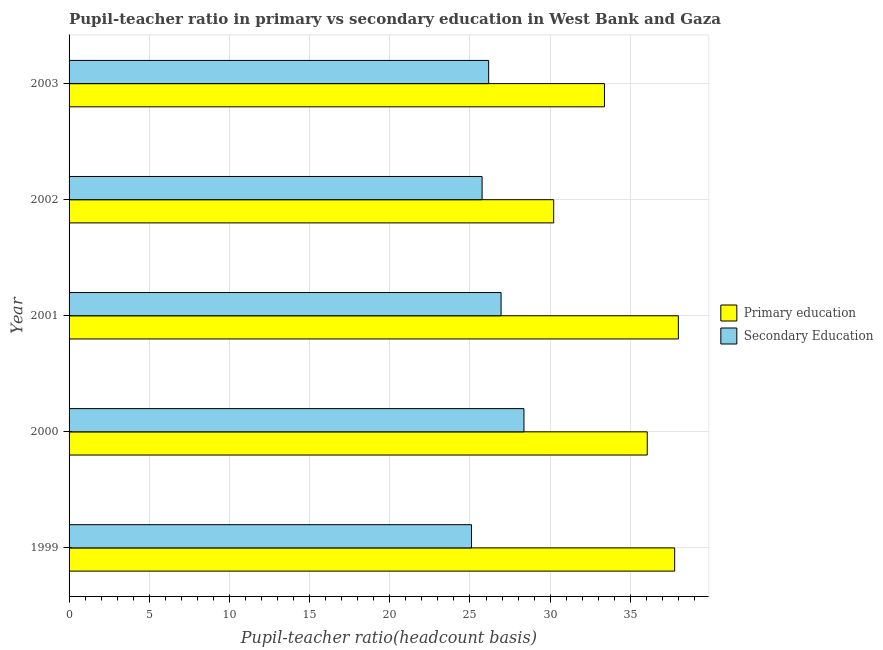How many different coloured bars are there?
Give a very brief answer. 2. How many groups of bars are there?
Your response must be concise. 5. Are the number of bars per tick equal to the number of legend labels?
Your response must be concise. Yes. How many bars are there on the 4th tick from the top?
Your response must be concise. 2. What is the pupil teacher ratio on secondary education in 2002?
Ensure brevity in your answer.  25.76. Across all years, what is the maximum pupil-teacher ratio in primary education?
Your answer should be compact. 37.99. Across all years, what is the minimum pupil teacher ratio on secondary education?
Make the answer very short. 25.1. In which year was the pupil-teacher ratio in primary education maximum?
Your response must be concise. 2001. What is the total pupil-teacher ratio in primary education in the graph?
Your answer should be very brief. 175.42. What is the difference between the pupil-teacher ratio in primary education in 1999 and that in 2002?
Provide a succinct answer. 7.55. What is the difference between the pupil-teacher ratio in primary education in 1999 and the pupil teacher ratio on secondary education in 2001?
Ensure brevity in your answer.  10.83. What is the average pupil-teacher ratio in primary education per year?
Offer a very short reply. 35.08. In the year 2001, what is the difference between the pupil teacher ratio on secondary education and pupil-teacher ratio in primary education?
Provide a short and direct response. -11.05. In how many years, is the pupil teacher ratio on secondary education greater than 22 ?
Your response must be concise. 5. What is the ratio of the pupil-teacher ratio in primary education in 1999 to that in 2000?
Keep it short and to the point. 1.05. What is the difference between the highest and the second highest pupil-teacher ratio in primary education?
Offer a very short reply. 0.23. What is the difference between the highest and the lowest pupil-teacher ratio in primary education?
Your answer should be compact. 7.77. Is the sum of the pupil-teacher ratio in primary education in 1999 and 2000 greater than the maximum pupil teacher ratio on secondary education across all years?
Your answer should be very brief. Yes. What does the 2nd bar from the top in 2001 represents?
Offer a very short reply. Primary education. What does the 1st bar from the bottom in 2003 represents?
Ensure brevity in your answer.  Primary education. How many bars are there?
Offer a very short reply. 10. Are the values on the major ticks of X-axis written in scientific E-notation?
Ensure brevity in your answer.  No. Does the graph contain grids?
Provide a short and direct response. Yes. How many legend labels are there?
Offer a terse response. 2. How are the legend labels stacked?
Your answer should be very brief. Vertical. What is the title of the graph?
Give a very brief answer. Pupil-teacher ratio in primary vs secondary education in West Bank and Gaza. What is the label or title of the X-axis?
Your answer should be compact. Pupil-teacher ratio(headcount basis). What is the label or title of the Y-axis?
Offer a terse response. Year. What is the Pupil-teacher ratio(headcount basis) in Primary education in 1999?
Offer a terse response. 37.76. What is the Pupil-teacher ratio(headcount basis) in Secondary Education in 1999?
Provide a succinct answer. 25.1. What is the Pupil-teacher ratio(headcount basis) in Primary education in 2000?
Give a very brief answer. 36.05. What is the Pupil-teacher ratio(headcount basis) of Secondary Education in 2000?
Offer a terse response. 28.37. What is the Pupil-teacher ratio(headcount basis) of Primary education in 2001?
Offer a terse response. 37.99. What is the Pupil-teacher ratio(headcount basis) in Secondary Education in 2001?
Your answer should be compact. 26.94. What is the Pupil-teacher ratio(headcount basis) of Primary education in 2002?
Offer a very short reply. 30.22. What is the Pupil-teacher ratio(headcount basis) in Secondary Education in 2002?
Your response must be concise. 25.76. What is the Pupil-teacher ratio(headcount basis) in Primary education in 2003?
Give a very brief answer. 33.39. What is the Pupil-teacher ratio(headcount basis) in Secondary Education in 2003?
Offer a terse response. 26.17. Across all years, what is the maximum Pupil-teacher ratio(headcount basis) in Primary education?
Offer a very short reply. 37.99. Across all years, what is the maximum Pupil-teacher ratio(headcount basis) of Secondary Education?
Offer a terse response. 28.37. Across all years, what is the minimum Pupil-teacher ratio(headcount basis) of Primary education?
Keep it short and to the point. 30.22. Across all years, what is the minimum Pupil-teacher ratio(headcount basis) of Secondary Education?
Provide a short and direct response. 25.1. What is the total Pupil-teacher ratio(headcount basis) in Primary education in the graph?
Make the answer very short. 175.42. What is the total Pupil-teacher ratio(headcount basis) of Secondary Education in the graph?
Offer a very short reply. 132.32. What is the difference between the Pupil-teacher ratio(headcount basis) in Primary education in 1999 and that in 2000?
Your answer should be very brief. 1.71. What is the difference between the Pupil-teacher ratio(headcount basis) in Secondary Education in 1999 and that in 2000?
Your answer should be very brief. -3.27. What is the difference between the Pupil-teacher ratio(headcount basis) of Primary education in 1999 and that in 2001?
Your response must be concise. -0.23. What is the difference between the Pupil-teacher ratio(headcount basis) in Secondary Education in 1999 and that in 2001?
Make the answer very short. -1.84. What is the difference between the Pupil-teacher ratio(headcount basis) in Primary education in 1999 and that in 2002?
Provide a short and direct response. 7.55. What is the difference between the Pupil-teacher ratio(headcount basis) of Secondary Education in 1999 and that in 2002?
Give a very brief answer. -0.66. What is the difference between the Pupil-teacher ratio(headcount basis) of Primary education in 1999 and that in 2003?
Make the answer very short. 4.38. What is the difference between the Pupil-teacher ratio(headcount basis) of Secondary Education in 1999 and that in 2003?
Offer a terse response. -1.07. What is the difference between the Pupil-teacher ratio(headcount basis) of Primary education in 2000 and that in 2001?
Your response must be concise. -1.94. What is the difference between the Pupil-teacher ratio(headcount basis) of Secondary Education in 2000 and that in 2001?
Provide a succinct answer. 1.43. What is the difference between the Pupil-teacher ratio(headcount basis) of Primary education in 2000 and that in 2002?
Your answer should be compact. 5.84. What is the difference between the Pupil-teacher ratio(headcount basis) of Secondary Education in 2000 and that in 2002?
Offer a terse response. 2.61. What is the difference between the Pupil-teacher ratio(headcount basis) in Primary education in 2000 and that in 2003?
Keep it short and to the point. 2.67. What is the difference between the Pupil-teacher ratio(headcount basis) in Secondary Education in 2000 and that in 2003?
Offer a very short reply. 2.2. What is the difference between the Pupil-teacher ratio(headcount basis) in Primary education in 2001 and that in 2002?
Make the answer very short. 7.78. What is the difference between the Pupil-teacher ratio(headcount basis) of Secondary Education in 2001 and that in 2002?
Offer a very short reply. 1.18. What is the difference between the Pupil-teacher ratio(headcount basis) in Primary education in 2001 and that in 2003?
Make the answer very short. 4.61. What is the difference between the Pupil-teacher ratio(headcount basis) in Secondary Education in 2001 and that in 2003?
Your answer should be very brief. 0.77. What is the difference between the Pupil-teacher ratio(headcount basis) in Primary education in 2002 and that in 2003?
Provide a short and direct response. -3.17. What is the difference between the Pupil-teacher ratio(headcount basis) of Secondary Education in 2002 and that in 2003?
Ensure brevity in your answer.  -0.41. What is the difference between the Pupil-teacher ratio(headcount basis) in Primary education in 1999 and the Pupil-teacher ratio(headcount basis) in Secondary Education in 2000?
Make the answer very short. 9.4. What is the difference between the Pupil-teacher ratio(headcount basis) of Primary education in 1999 and the Pupil-teacher ratio(headcount basis) of Secondary Education in 2001?
Offer a terse response. 10.82. What is the difference between the Pupil-teacher ratio(headcount basis) in Primary education in 1999 and the Pupil-teacher ratio(headcount basis) in Secondary Education in 2002?
Your answer should be very brief. 12.01. What is the difference between the Pupil-teacher ratio(headcount basis) in Primary education in 1999 and the Pupil-teacher ratio(headcount basis) in Secondary Education in 2003?
Your response must be concise. 11.6. What is the difference between the Pupil-teacher ratio(headcount basis) in Primary education in 2000 and the Pupil-teacher ratio(headcount basis) in Secondary Education in 2001?
Provide a succinct answer. 9.11. What is the difference between the Pupil-teacher ratio(headcount basis) in Primary education in 2000 and the Pupil-teacher ratio(headcount basis) in Secondary Education in 2002?
Provide a succinct answer. 10.3. What is the difference between the Pupil-teacher ratio(headcount basis) of Primary education in 2000 and the Pupil-teacher ratio(headcount basis) of Secondary Education in 2003?
Your answer should be very brief. 9.89. What is the difference between the Pupil-teacher ratio(headcount basis) in Primary education in 2001 and the Pupil-teacher ratio(headcount basis) in Secondary Education in 2002?
Provide a short and direct response. 12.24. What is the difference between the Pupil-teacher ratio(headcount basis) of Primary education in 2001 and the Pupil-teacher ratio(headcount basis) of Secondary Education in 2003?
Offer a terse response. 11.83. What is the difference between the Pupil-teacher ratio(headcount basis) in Primary education in 2002 and the Pupil-teacher ratio(headcount basis) in Secondary Education in 2003?
Keep it short and to the point. 4.05. What is the average Pupil-teacher ratio(headcount basis) in Primary education per year?
Your answer should be very brief. 35.08. What is the average Pupil-teacher ratio(headcount basis) in Secondary Education per year?
Ensure brevity in your answer.  26.46. In the year 1999, what is the difference between the Pupil-teacher ratio(headcount basis) of Primary education and Pupil-teacher ratio(headcount basis) of Secondary Education?
Offer a terse response. 12.67. In the year 2000, what is the difference between the Pupil-teacher ratio(headcount basis) of Primary education and Pupil-teacher ratio(headcount basis) of Secondary Education?
Your answer should be very brief. 7.69. In the year 2001, what is the difference between the Pupil-teacher ratio(headcount basis) in Primary education and Pupil-teacher ratio(headcount basis) in Secondary Education?
Offer a terse response. 11.05. In the year 2002, what is the difference between the Pupil-teacher ratio(headcount basis) of Primary education and Pupil-teacher ratio(headcount basis) of Secondary Education?
Your response must be concise. 4.46. In the year 2003, what is the difference between the Pupil-teacher ratio(headcount basis) in Primary education and Pupil-teacher ratio(headcount basis) in Secondary Education?
Your response must be concise. 7.22. What is the ratio of the Pupil-teacher ratio(headcount basis) of Primary education in 1999 to that in 2000?
Ensure brevity in your answer.  1.05. What is the ratio of the Pupil-teacher ratio(headcount basis) of Secondary Education in 1999 to that in 2000?
Provide a short and direct response. 0.88. What is the ratio of the Pupil-teacher ratio(headcount basis) of Primary education in 1999 to that in 2001?
Ensure brevity in your answer.  0.99. What is the ratio of the Pupil-teacher ratio(headcount basis) in Secondary Education in 1999 to that in 2001?
Give a very brief answer. 0.93. What is the ratio of the Pupil-teacher ratio(headcount basis) of Primary education in 1999 to that in 2002?
Keep it short and to the point. 1.25. What is the ratio of the Pupil-teacher ratio(headcount basis) of Secondary Education in 1999 to that in 2002?
Keep it short and to the point. 0.97. What is the ratio of the Pupil-teacher ratio(headcount basis) in Primary education in 1999 to that in 2003?
Offer a terse response. 1.13. What is the ratio of the Pupil-teacher ratio(headcount basis) of Secondary Education in 1999 to that in 2003?
Keep it short and to the point. 0.96. What is the ratio of the Pupil-teacher ratio(headcount basis) of Primary education in 2000 to that in 2001?
Your response must be concise. 0.95. What is the ratio of the Pupil-teacher ratio(headcount basis) of Secondary Education in 2000 to that in 2001?
Offer a terse response. 1.05. What is the ratio of the Pupil-teacher ratio(headcount basis) of Primary education in 2000 to that in 2002?
Your answer should be very brief. 1.19. What is the ratio of the Pupil-teacher ratio(headcount basis) of Secondary Education in 2000 to that in 2002?
Your response must be concise. 1.1. What is the ratio of the Pupil-teacher ratio(headcount basis) in Primary education in 2000 to that in 2003?
Your answer should be very brief. 1.08. What is the ratio of the Pupil-teacher ratio(headcount basis) of Secondary Education in 2000 to that in 2003?
Provide a short and direct response. 1.08. What is the ratio of the Pupil-teacher ratio(headcount basis) in Primary education in 2001 to that in 2002?
Ensure brevity in your answer.  1.26. What is the ratio of the Pupil-teacher ratio(headcount basis) of Secondary Education in 2001 to that in 2002?
Ensure brevity in your answer.  1.05. What is the ratio of the Pupil-teacher ratio(headcount basis) of Primary education in 2001 to that in 2003?
Give a very brief answer. 1.14. What is the ratio of the Pupil-teacher ratio(headcount basis) of Secondary Education in 2001 to that in 2003?
Ensure brevity in your answer.  1.03. What is the ratio of the Pupil-teacher ratio(headcount basis) in Primary education in 2002 to that in 2003?
Your answer should be compact. 0.91. What is the ratio of the Pupil-teacher ratio(headcount basis) of Secondary Education in 2002 to that in 2003?
Your response must be concise. 0.98. What is the difference between the highest and the second highest Pupil-teacher ratio(headcount basis) in Primary education?
Your response must be concise. 0.23. What is the difference between the highest and the second highest Pupil-teacher ratio(headcount basis) in Secondary Education?
Your answer should be very brief. 1.43. What is the difference between the highest and the lowest Pupil-teacher ratio(headcount basis) in Primary education?
Your response must be concise. 7.78. What is the difference between the highest and the lowest Pupil-teacher ratio(headcount basis) of Secondary Education?
Give a very brief answer. 3.27. 